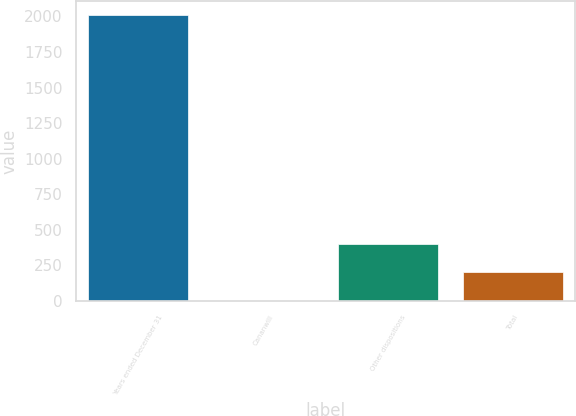Convert chart. <chart><loc_0><loc_0><loc_500><loc_500><bar_chart><fcel>Years ended December 31<fcel>Cananwill<fcel>Other dispositions<fcel>Total<nl><fcel>2009<fcel>2<fcel>403.4<fcel>202.7<nl></chart> 